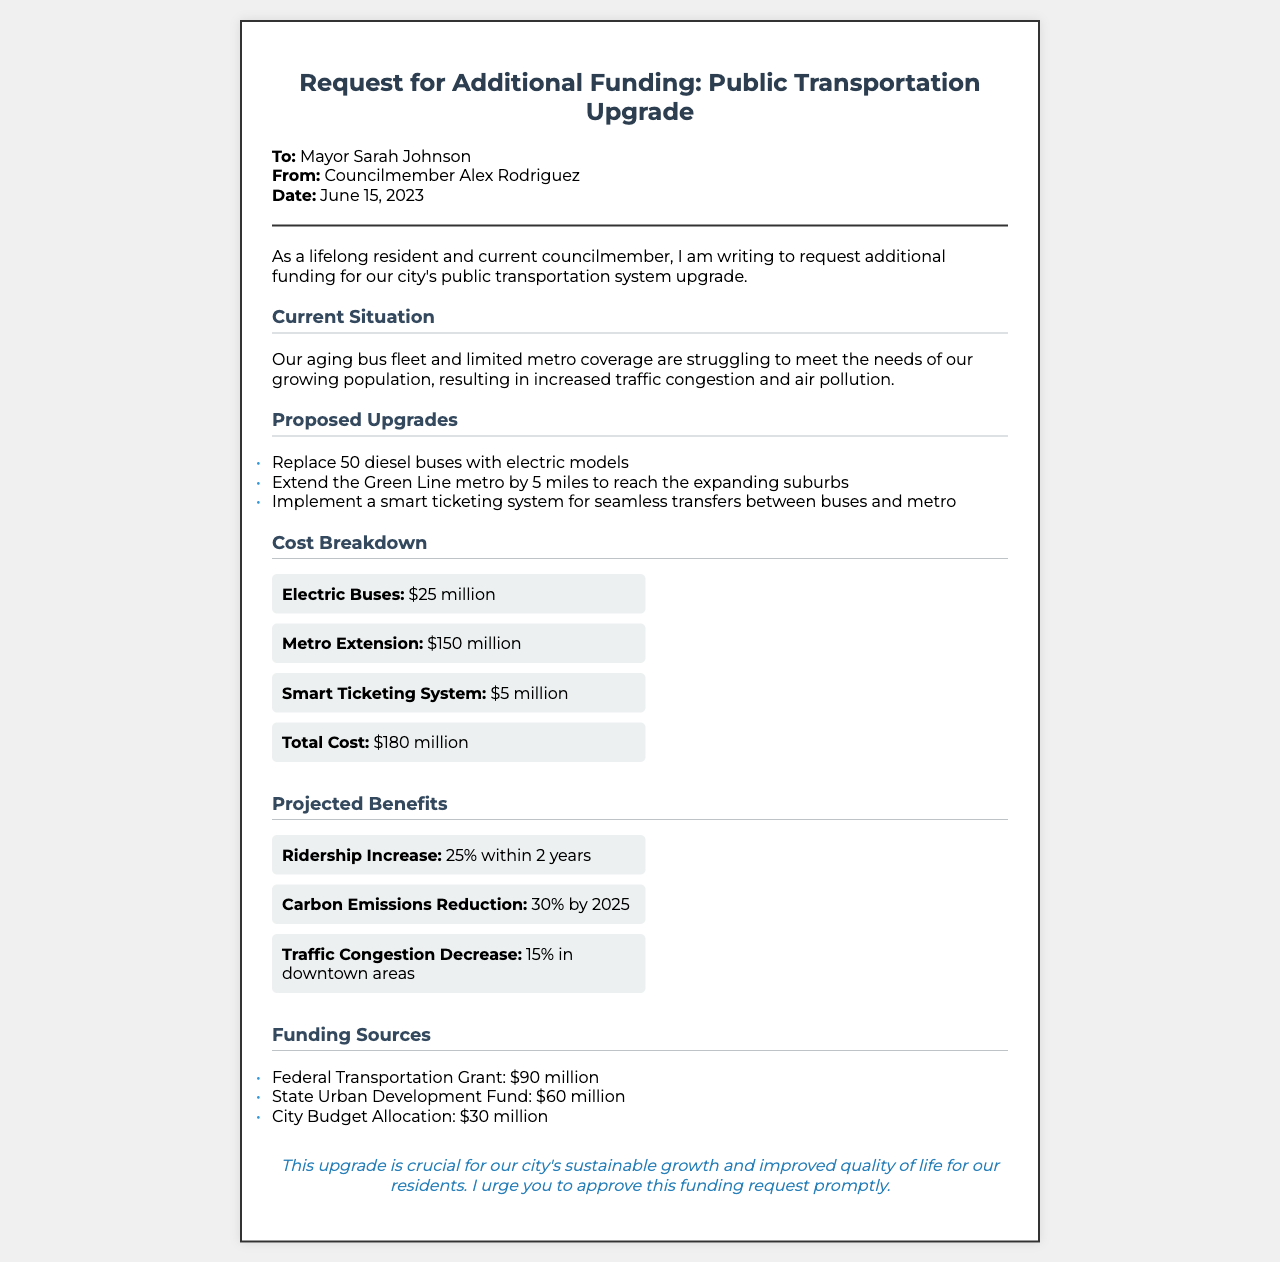What is the total cost of the upgrades? The total cost is listed in the cost breakdown section as $180 million.
Answer: $180 million Who is the recipient of the funding request? The recipient is mentioned in the document's header, indicating that the request is addressed to Mayor Sarah Johnson.
Answer: Mayor Sarah Johnson What is the increase in ridership projected within two years? The projected increase in ridership is stated as 25% within two years.
Answer: 25% How many diesel buses are proposed to be replaced? The document states that 50 diesel buses are proposed to be replaced with electric models.
Answer: 50 What is the expected reduction in carbon emissions by 2025? The document specifies a projected reduction of 30% in carbon emissions by 2025.
Answer: 30% Which funding source contributes the most to the total cost? The federal transportation grant, which contributes $90 million, is the largest funding source according to the funding sources section.
Answer: Federal Transportation Grant What is the total funding from state sources? The total funding from state sources includes the state urban development fund, contributing $60 million.
Answer: $60 million What is the date of the funding request? The date of the funding request is presented in the header as June 15, 2023.
Answer: June 15, 2023 What is the proposed smart system in the upgrades? The proposed upgrade includes implementing a smart ticketing system for seamless transfers between buses and metro.
Answer: Smart ticketing system 